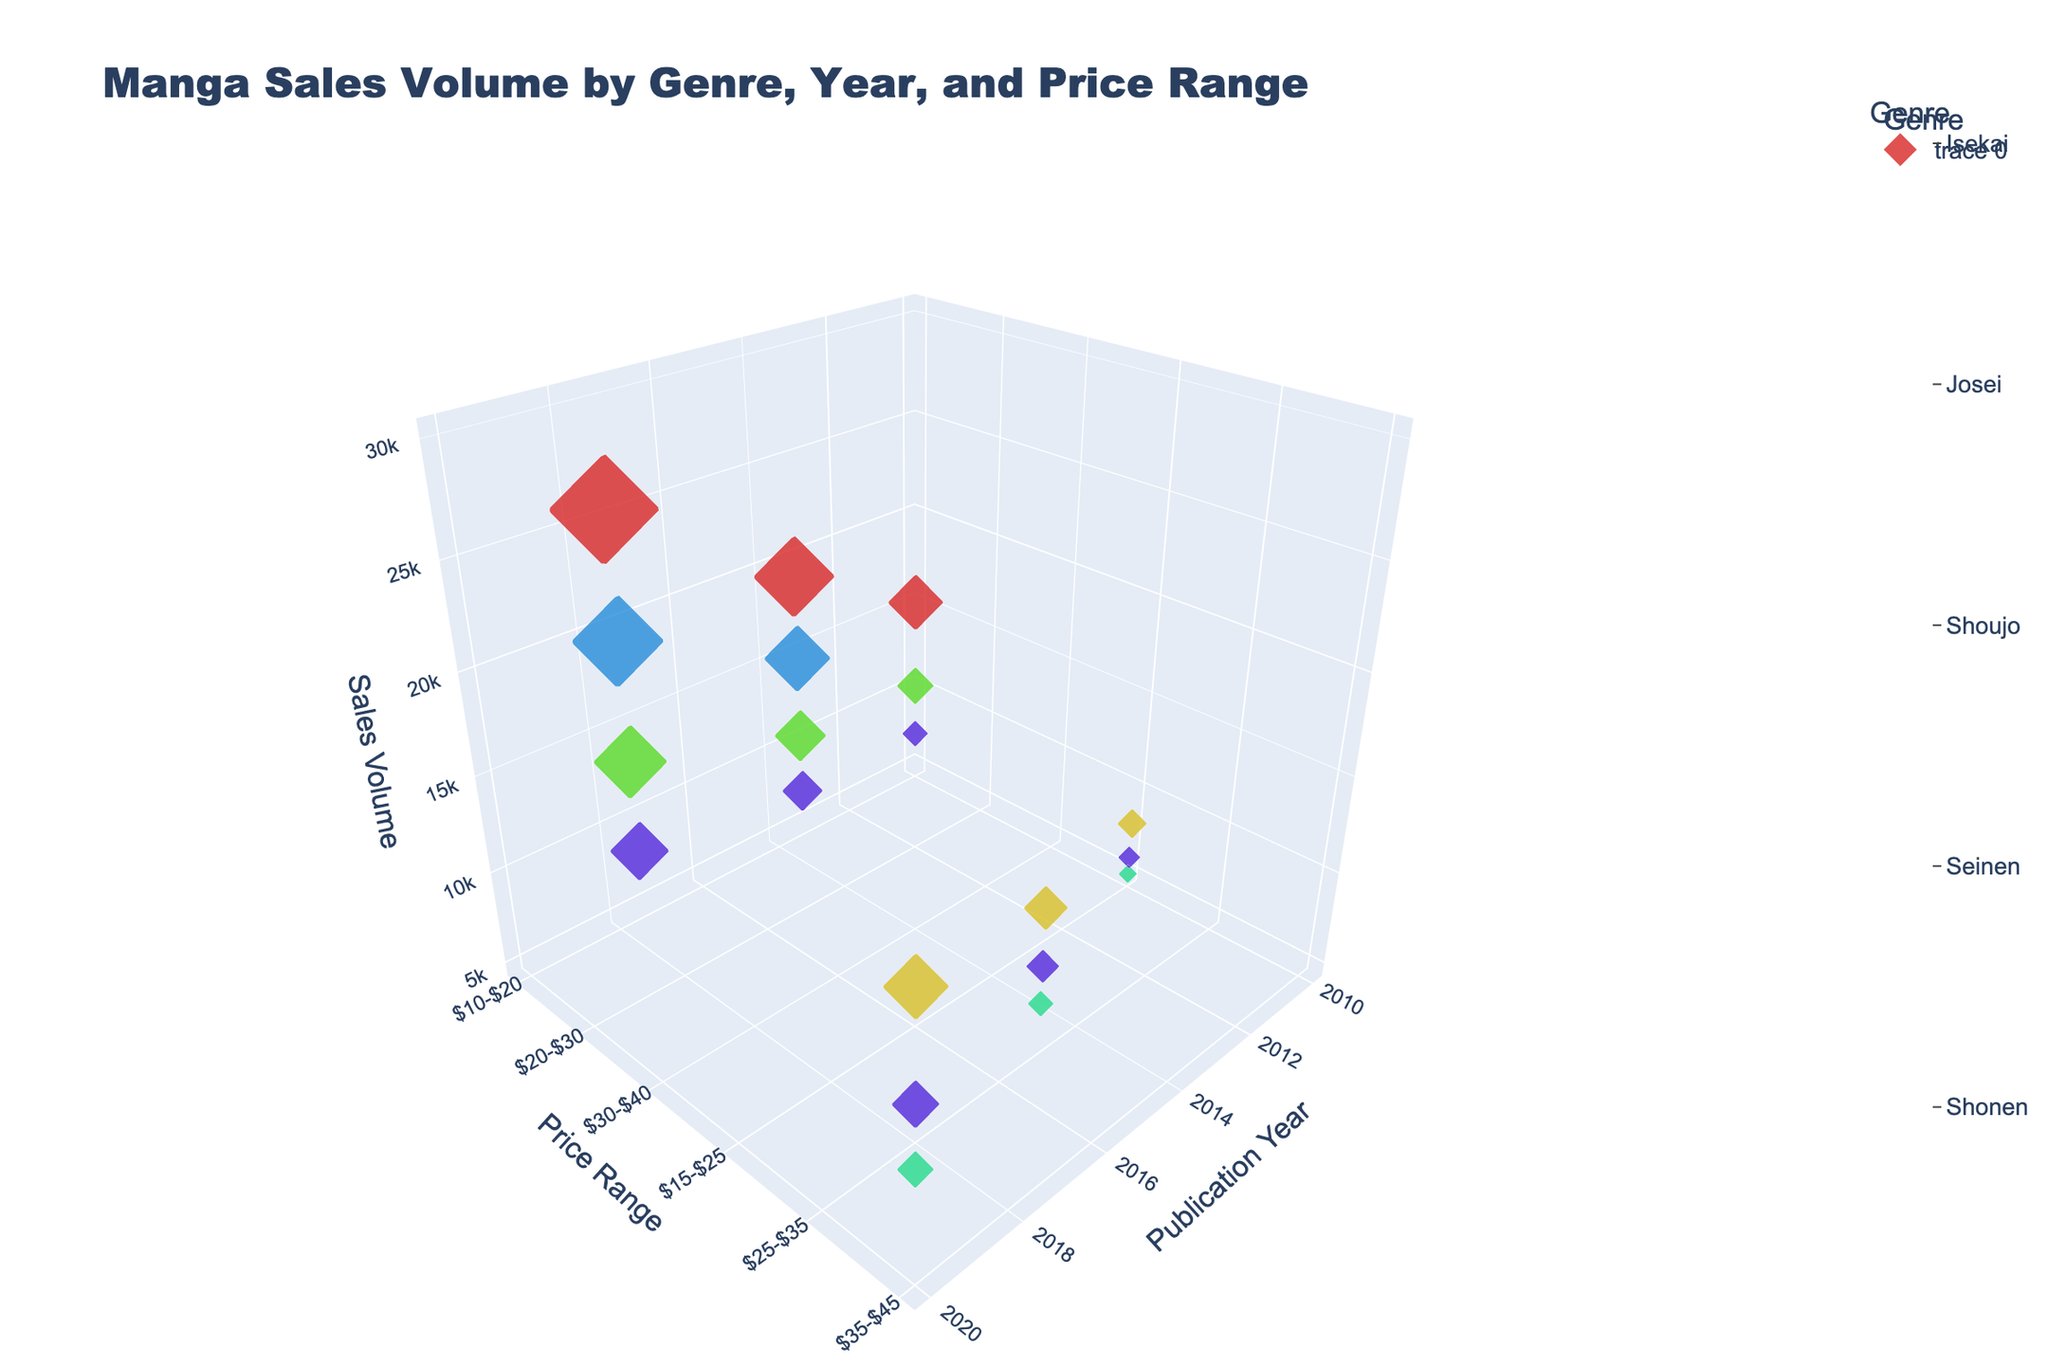How are the sales volumes distributed across genres in the year 2020? In the year 2020, the sales volumes for each genre can be identified from their respective positions along the 'Publication Year' axis and 'Sales Volume' axis. The volumes are: Shonen - 30000, Seinen - 18000, Shoujo - 20000, Josei - 10000, Isekai - 25000, Horror - 13000, Sports - 16000.
Answer: Shonen - 30000, Seinen - 18000, Shoujo - 20000, Josei - 10000, Isekai - 25000, Horror - 13000, Sports - 16000 How does the sales volume of Shonen manga compare to Seinen manga across years? By comparing the sales volumes of Shonen and Seinen manga for each year, we see: for 2010, Shonen - 15000 and Seinen - 8000; for 2015, Shonen - 22000 and Seinen - 12000; for 2020, Shonen - 30000 and Seinen - 18000. Shonen manga consistently has higher sales volumes each year.
Answer: Shonen > Seinen What is the total sales volume for all genres in the $20-$30 price range across all years? Summing up the sales volumes within the $20-$30 price range for 2015 and 2020, we have: Shonen - 22000 (2015), Shoujo - 14000 (2015), Isekai - 18000 (2015), Sports - 11000 (2015). Total = 22000 + 14000 + 18000 + 11000 = 65000.
Answer: 65000 Which genre has the highest sales volume in the $35-$45 price range? The genres with data points in the $35-$45 price range are Seinen (18000 in 2020), Josei (10000 in 2020), Horror (13000 in 2020). Among these, Seinen has the highest sales volume.
Answer: Seinen What are the sales volumes of the genres in 2010 with a price range between $10-$25? The sales volumes in 2010 with price ranges $10-$25 are: Shonen ($10-$20) - 15000, Shoujo ($10-$20) - 10000, Sports ($10-$20) - 7000, Seinen ($15-$25) - 8000, Josei ($15-$25) - 5000, Horror ($15-$25) - 6000.
Answer: Shonen: 15000, Shoujo: 10000, Sports: 7000, Seinen: 8000, Josei: 5000, Horror: 6000 How does the sales volume trend for Shoujo manga change from 2010 to 2020? Observing the data points for Shoujo manga across the years, the sales volume is 10000 in 2010, 14000 in 2015, and 20000 in 2020, showing a general increase over time.
Answer: Increasing trend What is the sales volume difference between Shoujo and Shonen manga in 2020? In 2020, Shoujo manga has a sales volume of 20000 and Shonen manga has 30000. The difference is 30000 - 20000 = 10000.
Answer: 10000 Which pair of genres has the closest sales volume in 2015? By comparing the sales volumes for each genre in 2015: Shonen - 22000, Seinen - 12000, Shoujo - 14000, Josei - 7000, Isekai - 18000, Horror - 9000, Sports - 11000. Shoujo (14000) and Seinen (12000) have the closest sales volumes, with a difference of 2000.
Answer: Shoujo and Seinen 